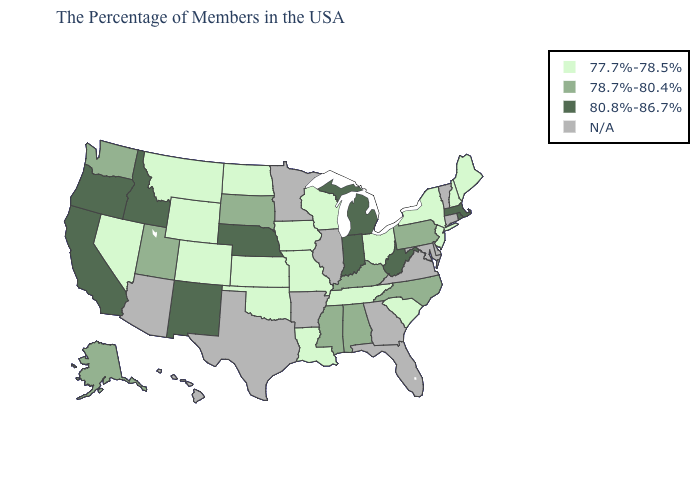What is the lowest value in the West?
Concise answer only. 77.7%-78.5%. What is the value of California?
Quick response, please. 80.8%-86.7%. What is the highest value in the USA?
Short answer required. 80.8%-86.7%. What is the value of Florida?
Answer briefly. N/A. Name the states that have a value in the range 77.7%-78.5%?
Give a very brief answer. Maine, New Hampshire, New York, New Jersey, South Carolina, Ohio, Tennessee, Wisconsin, Louisiana, Missouri, Iowa, Kansas, Oklahoma, North Dakota, Wyoming, Colorado, Montana, Nevada. Does the first symbol in the legend represent the smallest category?
Write a very short answer. Yes. Does the map have missing data?
Keep it brief. Yes. Which states have the lowest value in the West?
Concise answer only. Wyoming, Colorado, Montana, Nevada. Which states have the lowest value in the USA?
Short answer required. Maine, New Hampshire, New York, New Jersey, South Carolina, Ohio, Tennessee, Wisconsin, Louisiana, Missouri, Iowa, Kansas, Oklahoma, North Dakota, Wyoming, Colorado, Montana, Nevada. Does Maine have the highest value in the USA?
Concise answer only. No. Among the states that border North Dakota , does South Dakota have the highest value?
Answer briefly. Yes. Among the states that border California , which have the lowest value?
Answer briefly. Nevada. Does Washington have the lowest value in the USA?
Quick response, please. No. Which states have the lowest value in the USA?
Write a very short answer. Maine, New Hampshire, New York, New Jersey, South Carolina, Ohio, Tennessee, Wisconsin, Louisiana, Missouri, Iowa, Kansas, Oklahoma, North Dakota, Wyoming, Colorado, Montana, Nevada. 